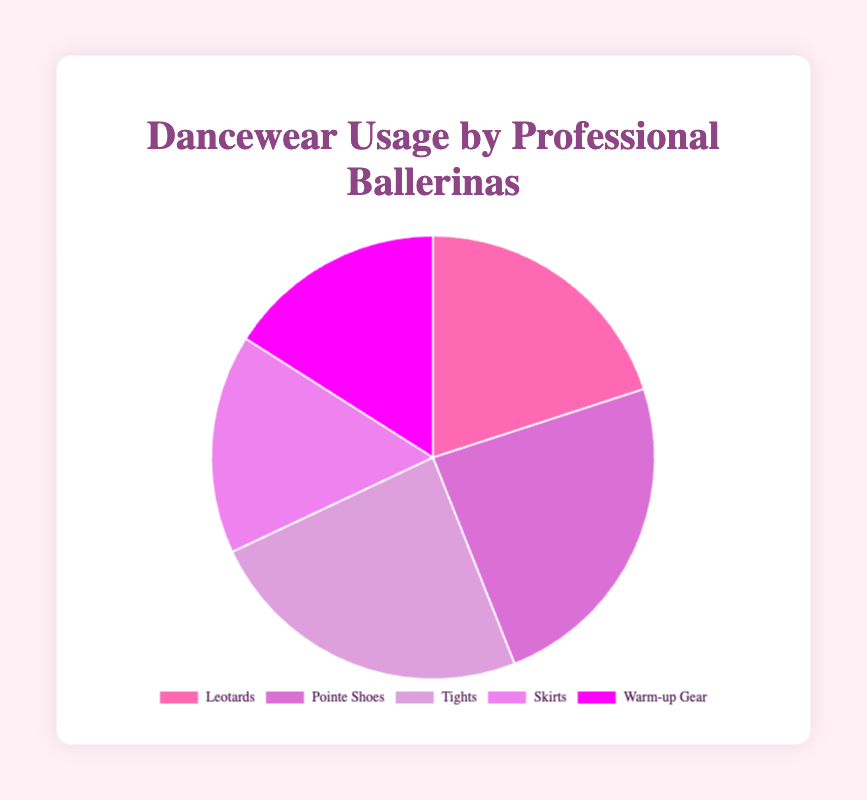Which type of dancewear is the most used by professional ballerinas? The figure shows the different types of dancewear and their usage percentages. The type with the largest slice represents the most used. Here, Pointe Shoes has the largest slice at 90%.
Answer: Pointe Shoes What is the total usage percentage for Leotards and Skirts combined? Add the usage percentages from the figure. Leotards are 75% and Skirts are 60%. So, 75 + 60 = 135%.
Answer: 135% Which dancewear category is used equally by professional ballerinas? Look for slices with the same size in the figure. Both Tights and Pointe Shoes each have a usage of 90%.
Answer: Tights and Pointe Shoes Is Warm-up Gear used less frequently than Leotards? Compare the slice sizes in the figure for each type. Leotards have a 75% usage while Warm-up Gear has 60%. Therefore, Warm-up Gear is used less frequently.
Answer: Yes What proportion of the total usage do Tights and Warm-up Gear together hold? Calculate the sum of their usage percentages from the figure. Tights are 90% and Warm-up Gear are 60%, so 90 + 60 = 150%. Divide by the total (5 types), 150/375 * 100% ≈ 40%.
Answer: 40% How much more frequently are Pointe Shoes used compared to Skirts? Subtract the percentage of Skirts from Pointe Shoes. Pointe Shoes are 90% and Skirts are 60%, so 90% - 60% = 30%.
Answer: 30% If you were to remove the usage of Warm-up Gear, what would be the new total percentage? Subtract the usage of Warm-up Gear from the total usage of all dancewear types. Total usage is 75 + 90 + 90 + 60 + 60 = 375%. Removing Warm-up Gear (60%) yields 375 - 60 = 315%.
Answer: 315% Which brand of Tights has the highest usage percentage? The figure doesn't provide detailed brand percentages but references them in the total usage for "Tights." Since the figure lists Tights as 90%, which includes the highest usage for the category, infer the brand from the provided data list. Tights by Capezio have 40%, the highest among Tights brands.
Answer: Capezio 